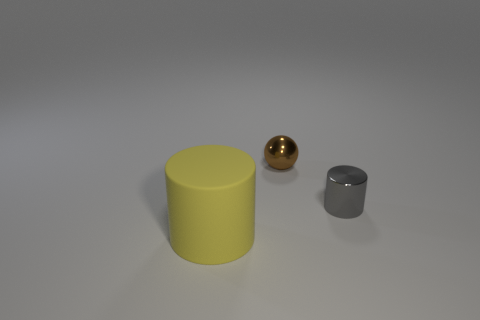What is the cylinder on the left side of the tiny object left of the small metal cylinder made of?
Your answer should be compact. Rubber. Are there any tiny spheres made of the same material as the small cylinder?
Provide a succinct answer. Yes. Is there a brown metallic object on the left side of the metallic object to the right of the ball?
Your response must be concise. Yes. There is a small thing that is to the right of the tiny brown shiny ball; what is its material?
Make the answer very short. Metal. Does the yellow object have the same shape as the small brown thing?
Give a very brief answer. No. What color is the cylinder on the right side of the small metal object that is behind the small object on the right side of the tiny brown metal thing?
Ensure brevity in your answer.  Gray. How many big objects are the same shape as the tiny brown shiny object?
Offer a terse response. 0. How big is the shiny object behind the cylinder that is behind the large yellow matte cylinder?
Offer a terse response. Small. Is the matte cylinder the same size as the metallic cylinder?
Offer a very short reply. No. There is a tiny thing behind the cylinder to the right of the brown ball; are there any matte cylinders behind it?
Offer a very short reply. No. 